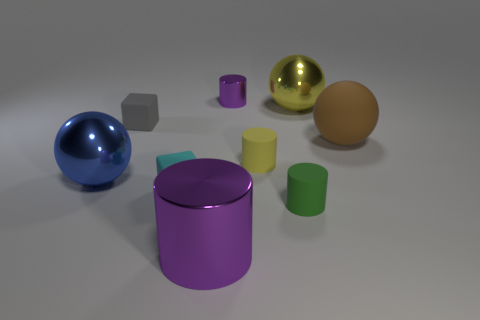What is the shape of the other object that is the same color as the small metallic thing?
Keep it short and to the point. Cylinder. What size is the metal thing that is the same color as the big metal cylinder?
Provide a short and direct response. Small. What material is the big brown sphere behind the big object that is in front of the tiny block in front of the large brown rubber thing?
Provide a short and direct response. Rubber. How big is the shiny thing that is both behind the brown matte sphere and in front of the tiny purple object?
Ensure brevity in your answer.  Large. Does the blue metallic object have the same shape as the tiny metallic thing?
Your answer should be compact. No. What shape is the green object that is made of the same material as the large brown object?
Offer a terse response. Cylinder. How many big objects are either yellow rubber cylinders or yellow things?
Make the answer very short. 1. Are there any gray matte blocks to the right of the metal cylinder behind the yellow matte object?
Offer a very short reply. No. Are there any big gray matte cylinders?
Offer a terse response. No. There is a cylinder in front of the tiny object that is in front of the cyan matte block; what is its color?
Give a very brief answer. Purple. 